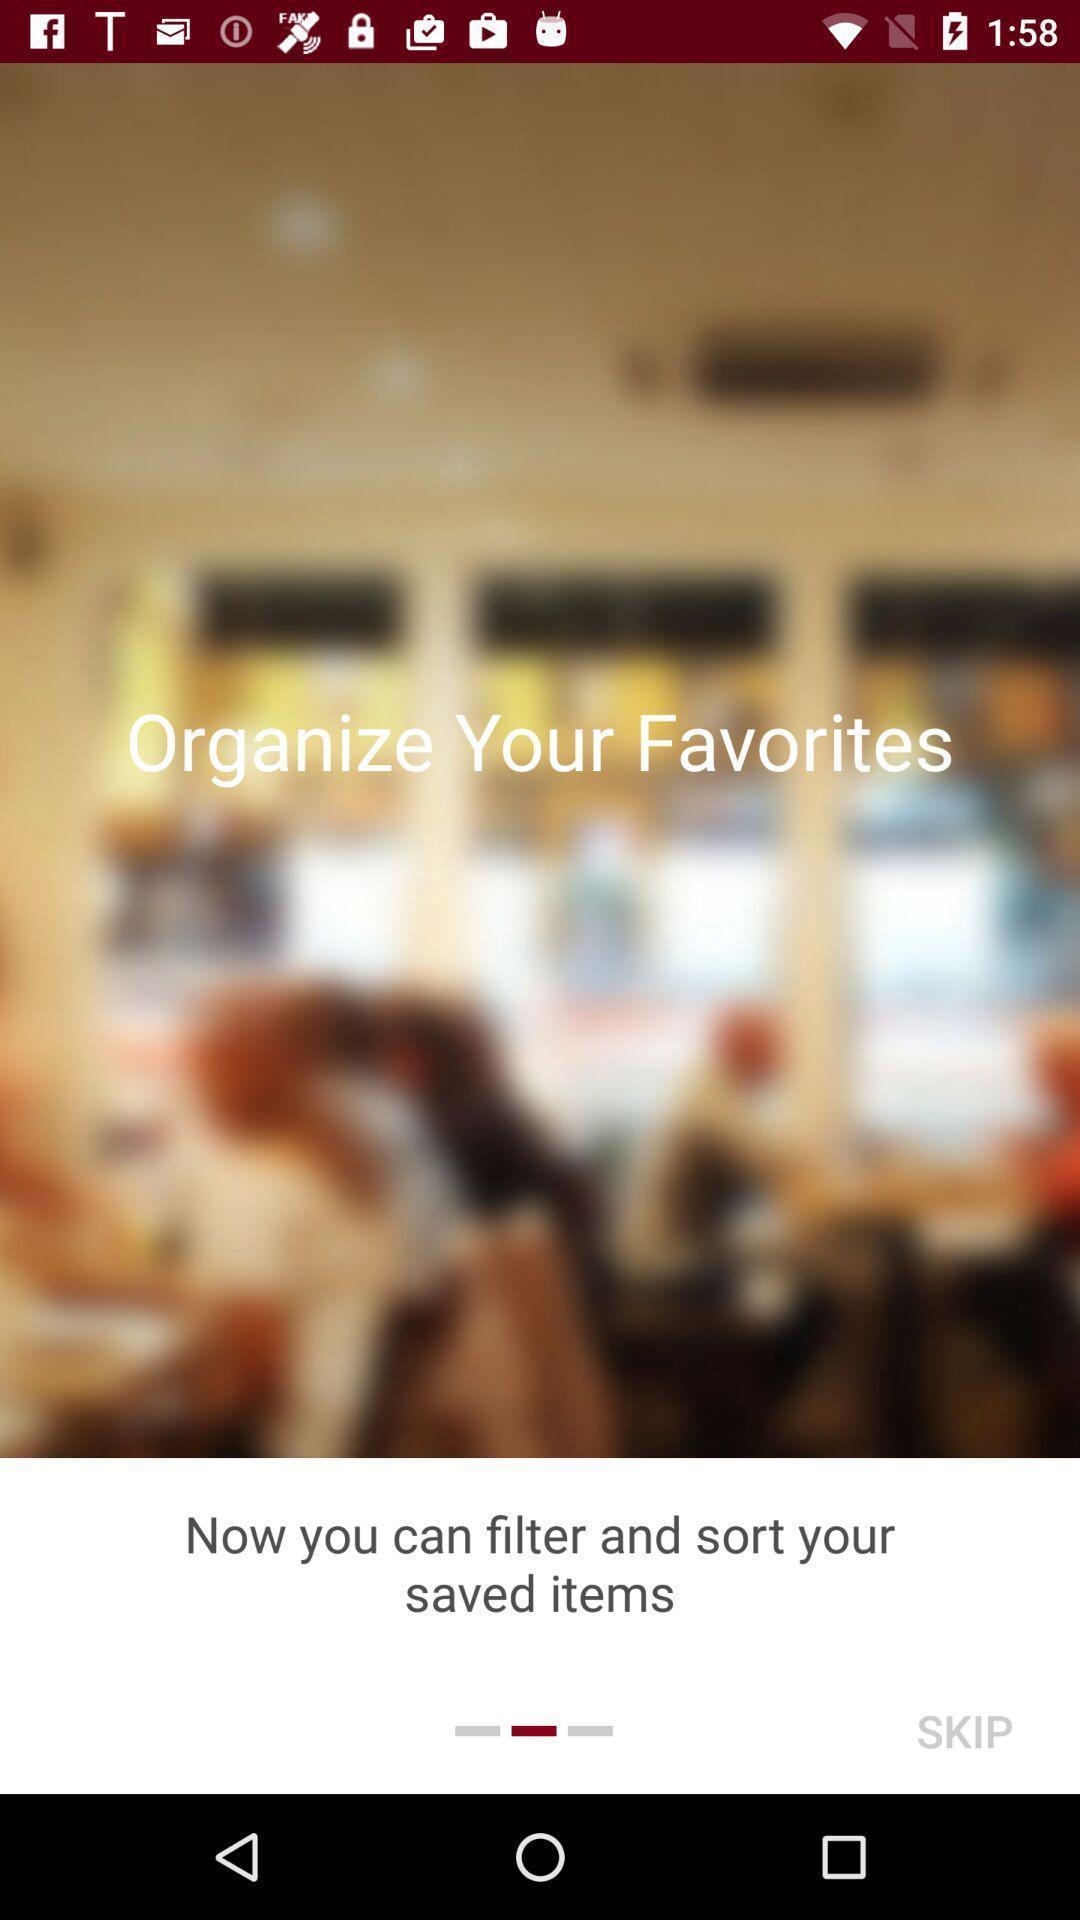Tell me what you see in this picture. Screen shows to organize favorites. 